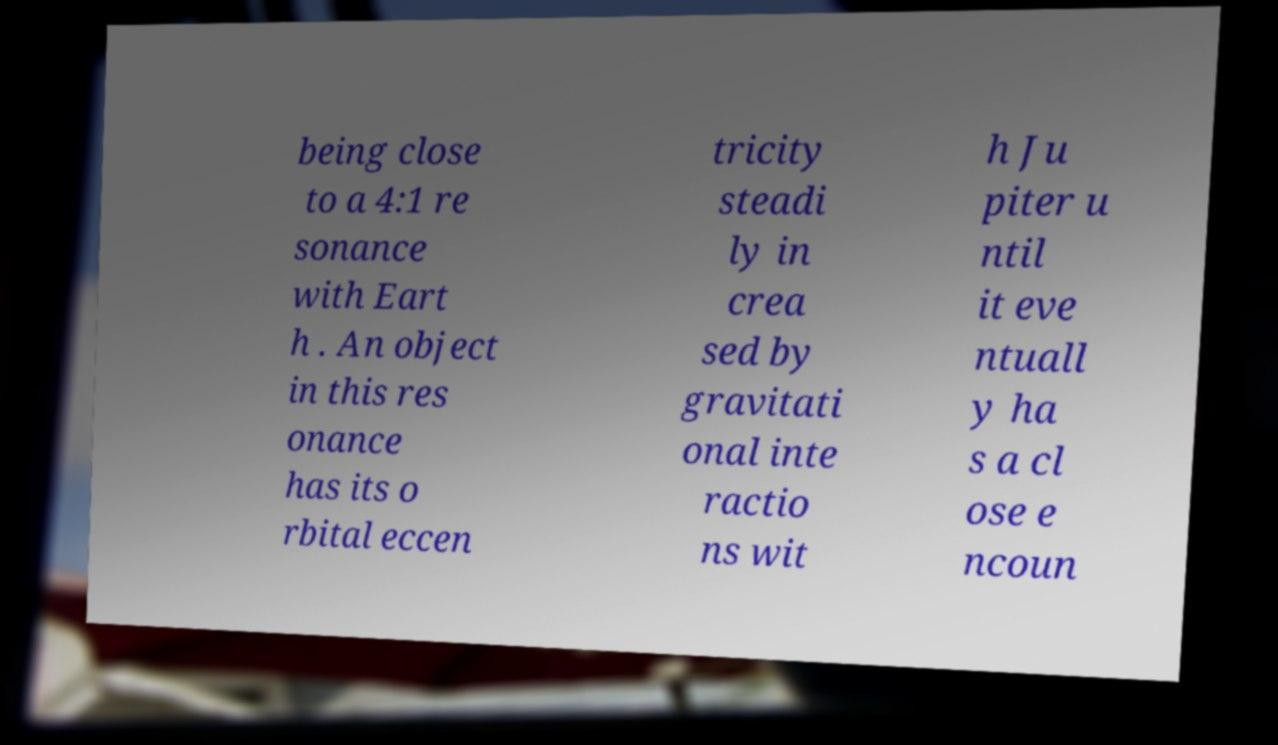Please read and relay the text visible in this image. What does it say? being close to a 4:1 re sonance with Eart h . An object in this res onance has its o rbital eccen tricity steadi ly in crea sed by gravitati onal inte ractio ns wit h Ju piter u ntil it eve ntuall y ha s a cl ose e ncoun 